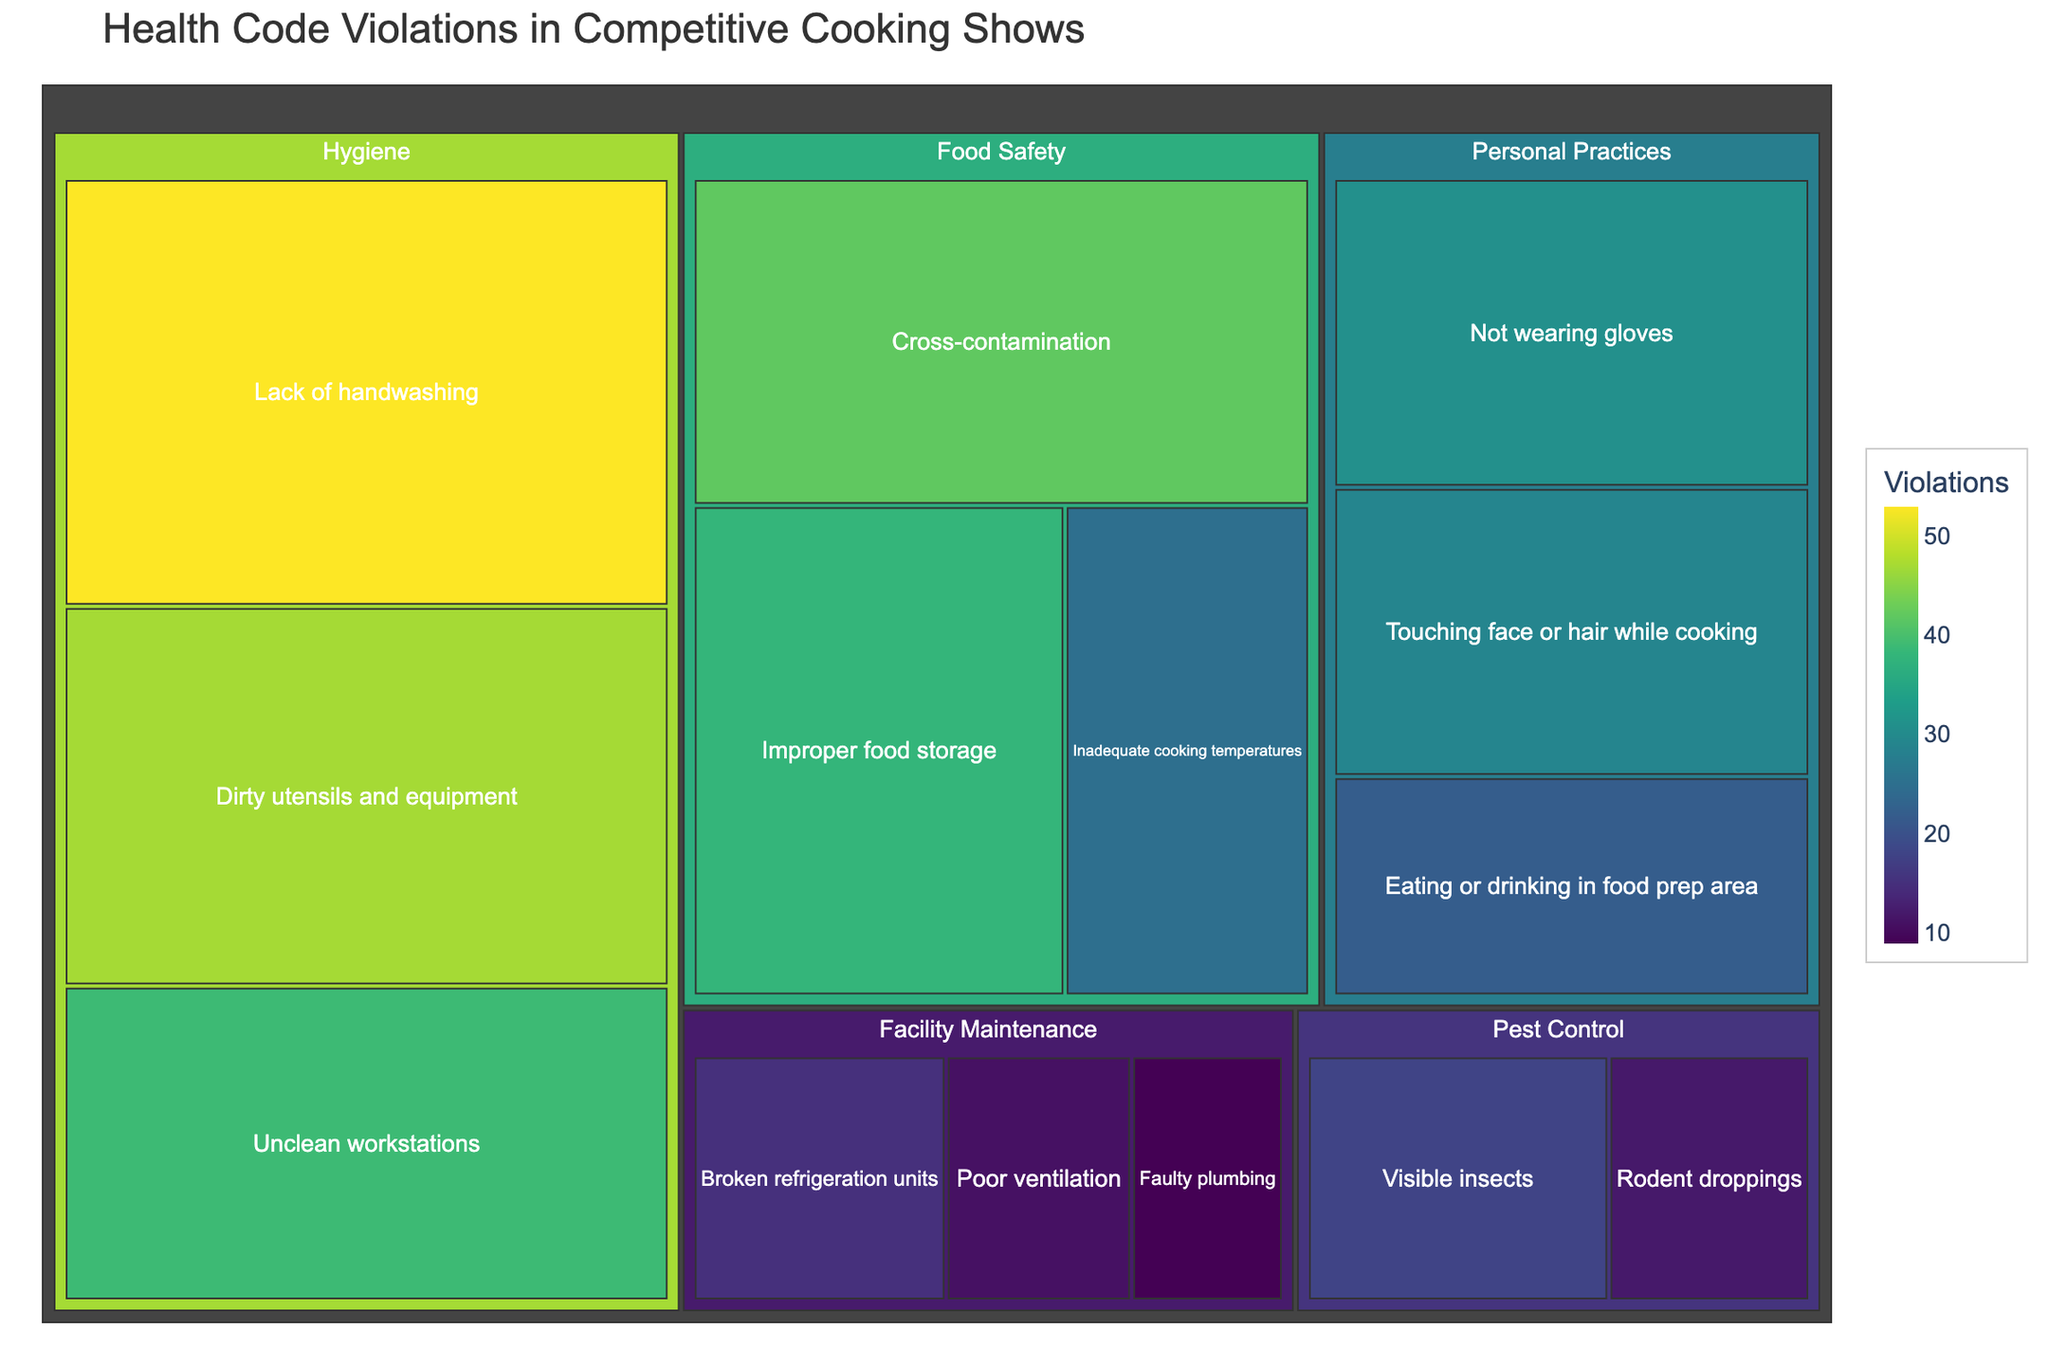What's the title of the Treemap? The title is usually located at the top of the Treemap and provides an overview of what the plot represents. Here, it helps identify that the plot shows health code violations in competitive cooking shows.
Answer: Health Code Violations in Competitive Cooking Shows How many subcategories are under the Hygiene category? Look for "Hygiene" in the plot and count the number of subcategories listed under it.
Answer: 3 Which subcategory has the highest number of violations? Identify the subcategory with the largest or most prominent area in the Treemap, as areas are proportional to the number of violations.
Answer: Lack of handwashing What is the total number of violations for the Food Safety category? Sum the violations for each subcategory under Food Safety: Cross-contamination (42) + Improper food storage (38) + Inadequate cooking temperatures (25). 42 + 38 + 25 = 105
Answer: 105 How many violations are associated with Unclean workstations? Locate the subcategory "Unclean workstations" and read the number of violations associated with it.
Answer: 39 Which category has the least number of total violations? Sum the violations for all subcategories under each category and identify the smallest sum. Facility Maintenance has:  Broken refrigeration units (15) + Poor ventilation (11) + Faulty plumbing (9). 15 + 11 + 9 = 35, verify if it is the smallest value comparing with other categories total violations sum.
Answer: Facility Maintenance How does the number of violations for Not wearing gloves compare to Touching face or hair while cooking? Find the number of violations for both subcategories and compare their values. Not wearing gloves: 31, Touching face or hair while cooking: 29. Compare 31 and 29.
Answer: Not wearing gloves has more violations What proportion of violations in the Food Safety category does Improper food storage represent? Divide the number of violations for "Improper food storage" by the total number of violations in the Food Safety category: 38 / 105 = 0.361 or 36.1%
Answer: 36.1% Which subcategory belongs to Pest Control and has the least violations? Under Pest Control, identify the subcategory with the smaller number: Visible insects (18) vs Rodent droppings (12). Compare 18 and 12.
Answer: Rodent droppings What is the sum of violations for the subcategories under Personal Practices? Sum the violations for all subcategories under Personal Practices: Not wearing gloves (31) + Touching face or hair while cooking (29) + Eating or drinking in food prep area (22). 31 + 29 + 22 = 82
Answer: 82 